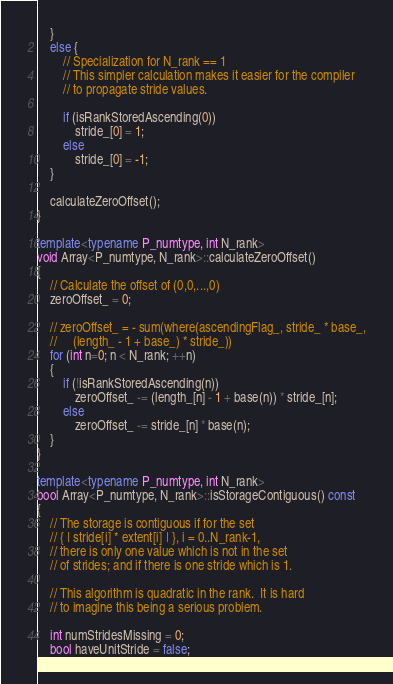Convert code to text. <code><loc_0><loc_0><loc_500><loc_500><_C++_>    }
    else {
        // Specialization for N_rank == 1
        // This simpler calculation makes it easier for the compiler
        // to propagate stride values.

        if (isRankStoredAscending(0))
            stride_[0] = 1;
        else
            stride_[0] = -1;
    }

    calculateZeroOffset();
}

template<typename P_numtype, int N_rank>
void Array<P_numtype, N_rank>::calculateZeroOffset()
{
    // Calculate the offset of (0,0,...,0)
    zeroOffset_ = 0;

    // zeroOffset_ = - sum(where(ascendingFlag_, stride_ * base_,
    //     (length_ - 1 + base_) * stride_))
    for (int n=0; n < N_rank; ++n)
    {
        if (!isRankStoredAscending(n))
            zeroOffset_ -= (length_[n] - 1 + base(n)) * stride_[n];
        else
            zeroOffset_ -= stride_[n] * base(n);
    }
}

template<typename P_numtype, int N_rank>
bool Array<P_numtype, N_rank>::isStorageContiguous() const
{
    // The storage is contiguous if for the set
    // { | stride[i] * extent[i] | }, i = 0..N_rank-1,
    // there is only one value which is not in the set
    // of strides; and if there is one stride which is 1.

    // This algorithm is quadratic in the rank.  It is hard
    // to imagine this being a serious problem.

    int numStridesMissing = 0;
    bool haveUnitStride = false;
</code> 